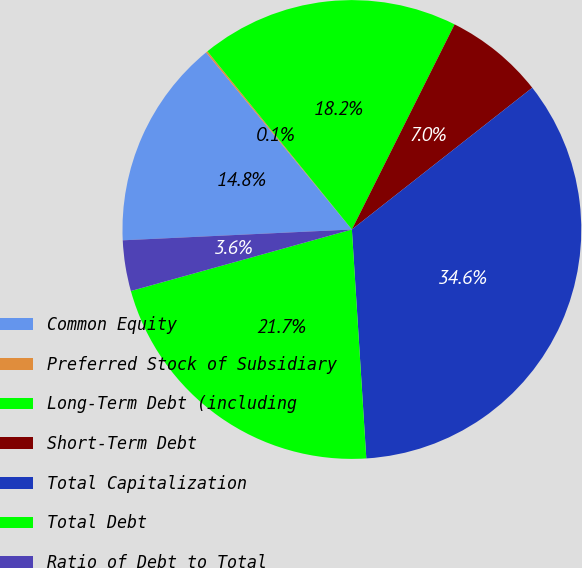Convert chart. <chart><loc_0><loc_0><loc_500><loc_500><pie_chart><fcel>Common Equity<fcel>Preferred Stock of Subsidiary<fcel>Long-Term Debt (including<fcel>Short-Term Debt<fcel>Total Capitalization<fcel>Total Debt<fcel>Ratio of Debt to Total<nl><fcel>14.79%<fcel>0.12%<fcel>18.23%<fcel>7.01%<fcel>34.6%<fcel>21.68%<fcel>3.57%<nl></chart> 